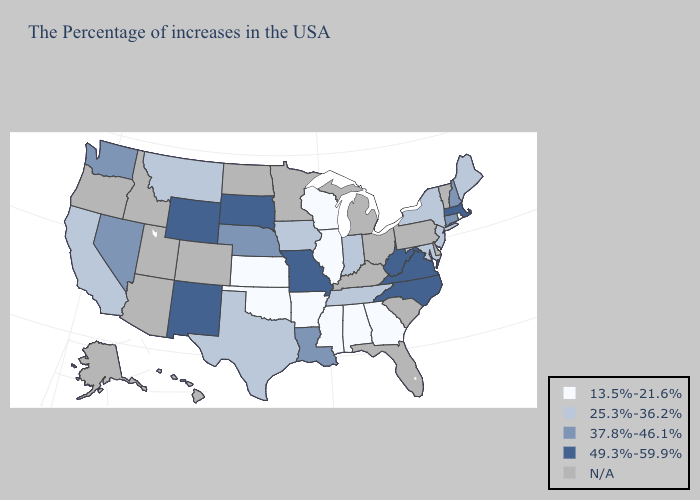Which states hav the highest value in the West?
Give a very brief answer. Wyoming, New Mexico. Name the states that have a value in the range 37.8%-46.1%?
Give a very brief answer. New Hampshire, Connecticut, Louisiana, Nebraska, Nevada, Washington. Does Wyoming have the highest value in the USA?
Concise answer only. Yes. Name the states that have a value in the range N/A?
Answer briefly. Vermont, Delaware, Pennsylvania, South Carolina, Ohio, Florida, Michigan, Kentucky, Minnesota, North Dakota, Colorado, Utah, Arizona, Idaho, Oregon, Alaska, Hawaii. Among the states that border Alabama , does Mississippi have the lowest value?
Answer briefly. Yes. Does Indiana have the highest value in the MidWest?
Be succinct. No. What is the lowest value in states that border Massachusetts?
Short answer required. 13.5%-21.6%. Does the map have missing data?
Write a very short answer. Yes. Does the map have missing data?
Write a very short answer. Yes. Which states have the lowest value in the USA?
Concise answer only. Rhode Island, Georgia, Alabama, Wisconsin, Illinois, Mississippi, Arkansas, Kansas, Oklahoma. Name the states that have a value in the range 13.5%-21.6%?
Answer briefly. Rhode Island, Georgia, Alabama, Wisconsin, Illinois, Mississippi, Arkansas, Kansas, Oklahoma. Among the states that border South Carolina , which have the lowest value?
Be succinct. Georgia. Is the legend a continuous bar?
Short answer required. No. 